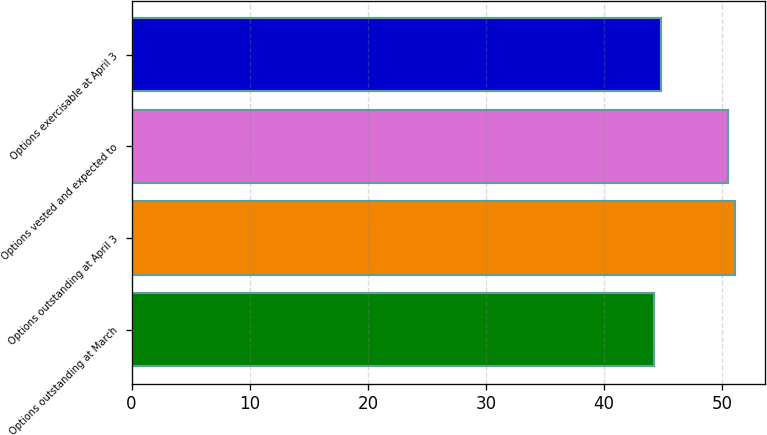Convert chart. <chart><loc_0><loc_0><loc_500><loc_500><bar_chart><fcel>Options outstanding at March<fcel>Options outstanding at April 3<fcel>Options vested and expected to<fcel>Options exercisable at April 3<nl><fcel>44.22<fcel>51.09<fcel>50.46<fcel>44.85<nl></chart> 